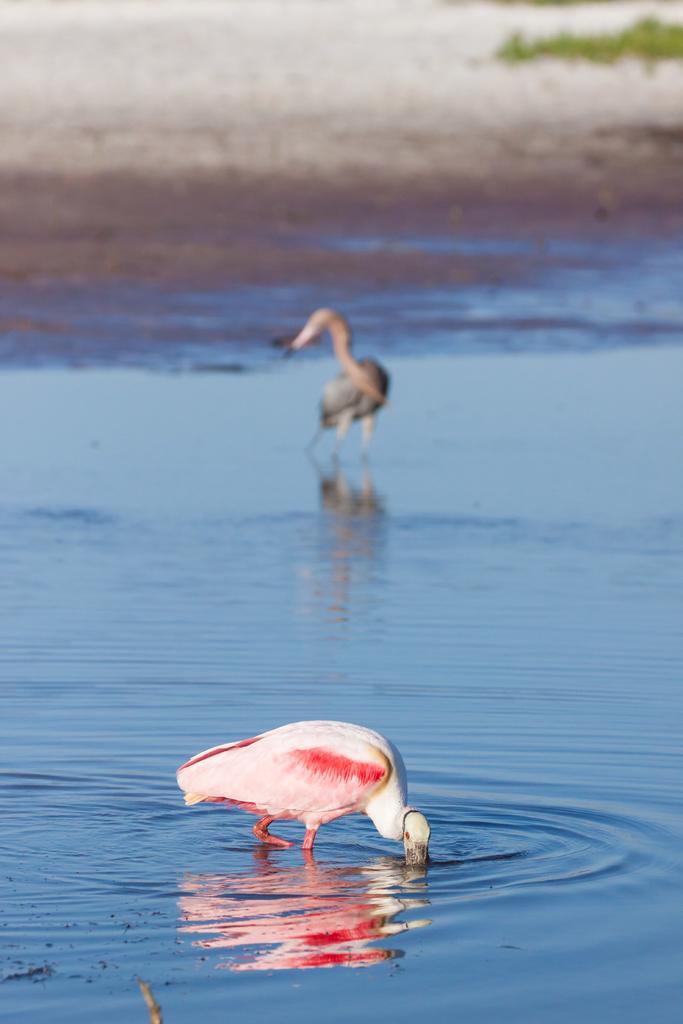Could you give a brief overview of what you see in this image? In the image we can see there are two birds in the water, there is a water, sand and a grass. 